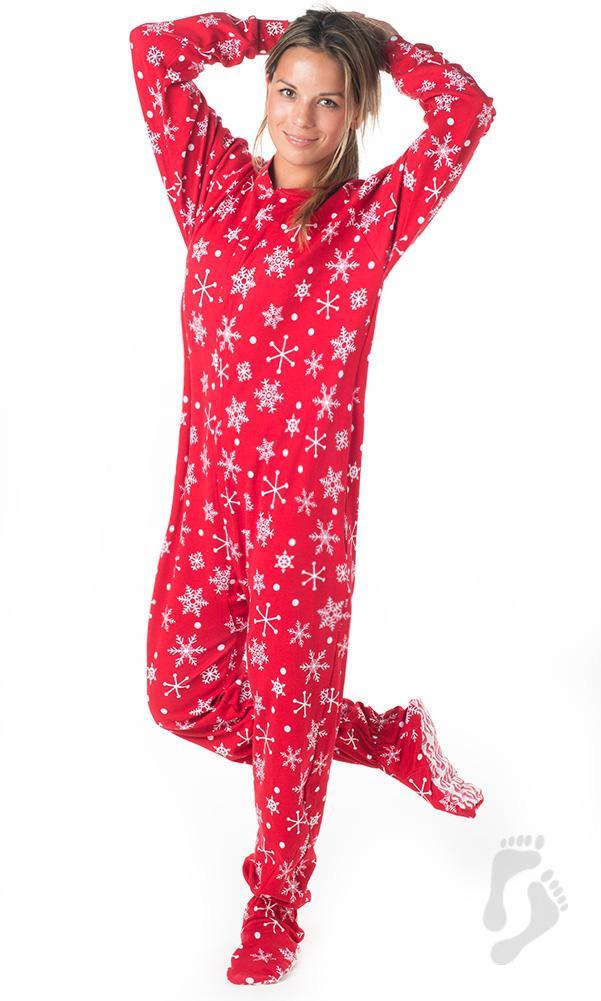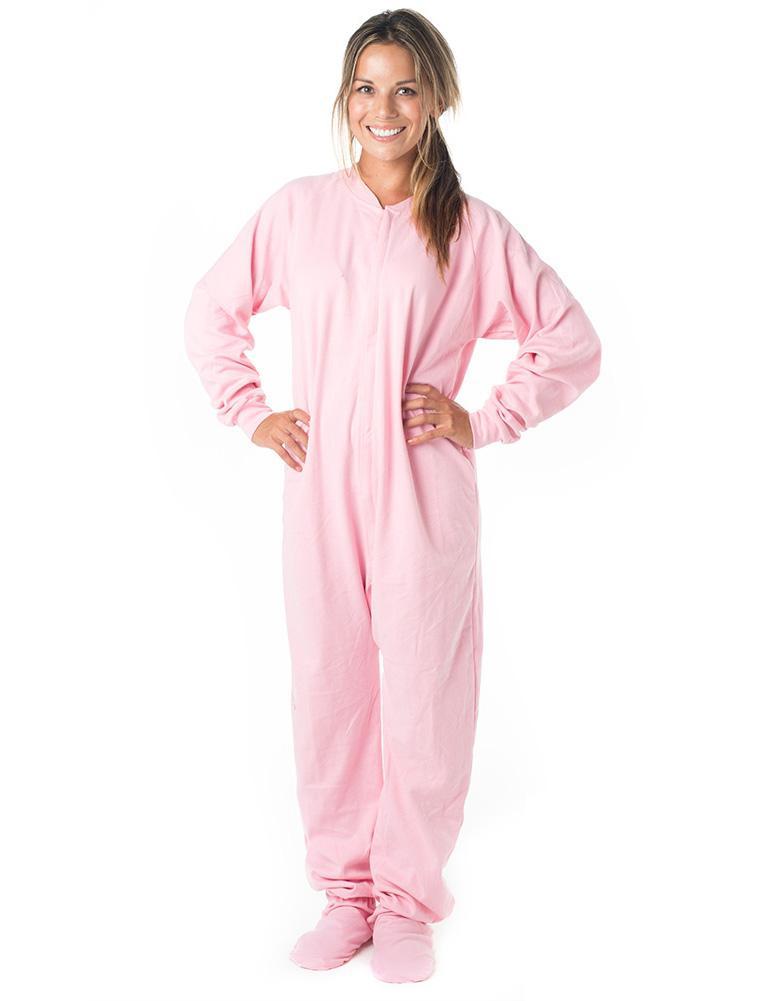The first image is the image on the left, the second image is the image on the right. Considering the images on both sides, is "There are two female wearing pajamas by themselves" valid? Answer yes or no. Yes. The first image is the image on the left, the second image is the image on the right. Given the left and right images, does the statement "There is at least one person with their hood up." hold true? Answer yes or no. No. 